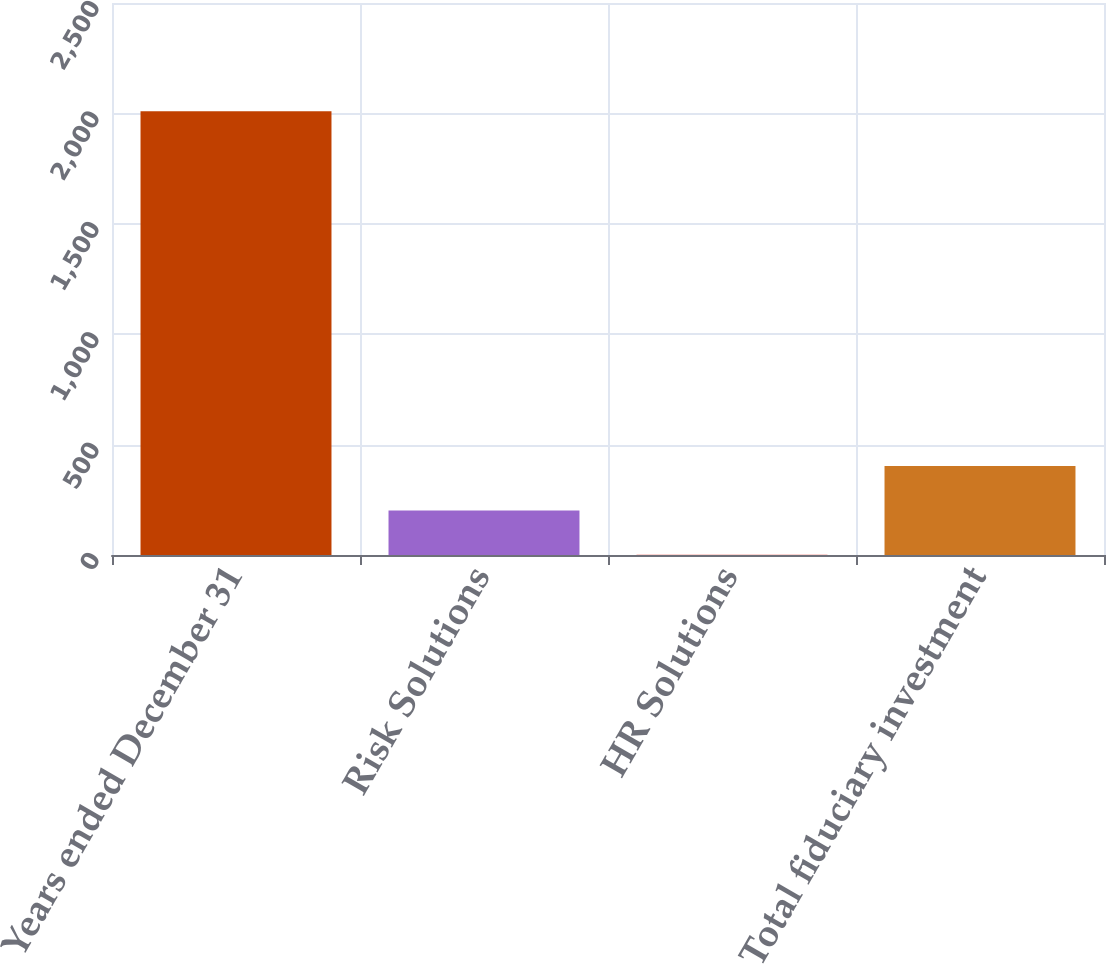<chart> <loc_0><loc_0><loc_500><loc_500><bar_chart><fcel>Years ended December 31<fcel>Risk Solutions<fcel>HR Solutions<fcel>Total fiduciary investment<nl><fcel>2010<fcel>201.9<fcel>1<fcel>402.8<nl></chart> 